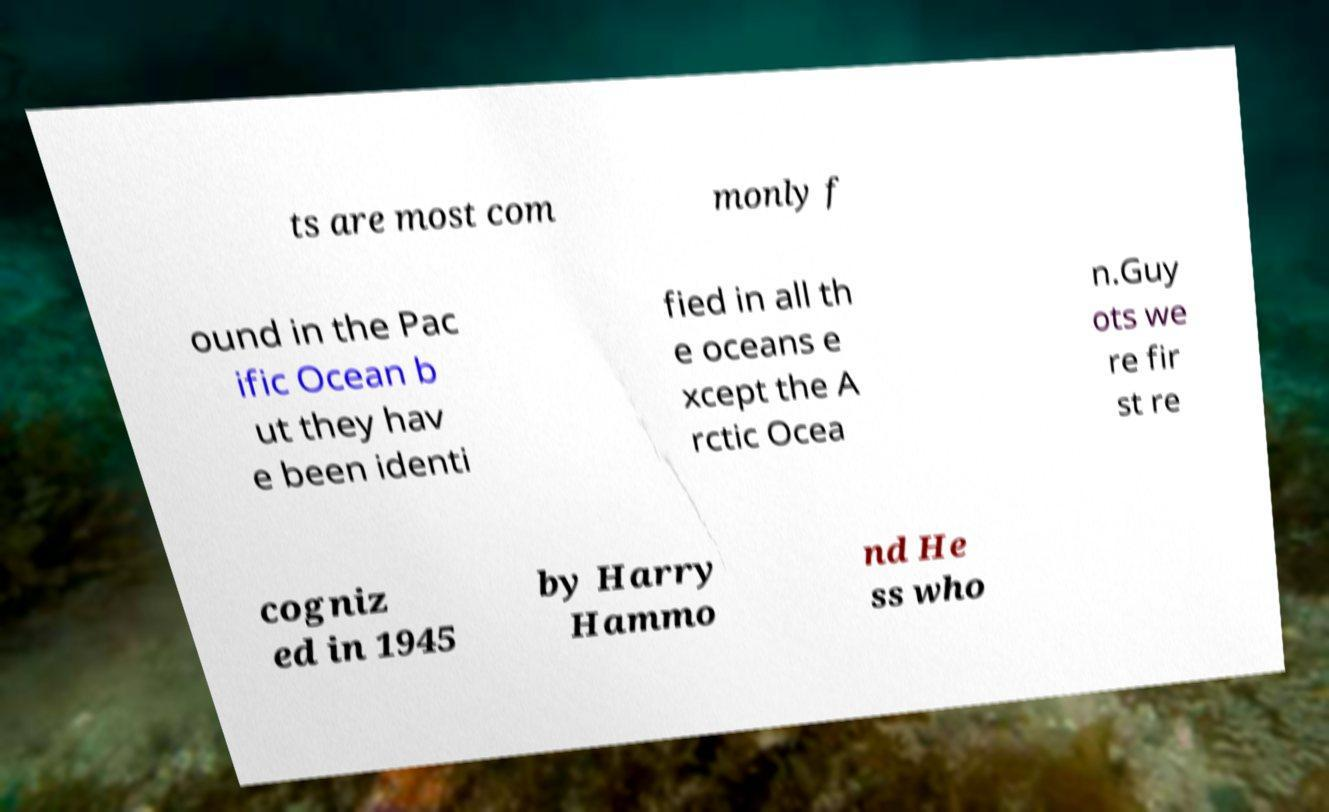Please read and relay the text visible in this image. What does it say? ts are most com monly f ound in the Pac ific Ocean b ut they hav e been identi fied in all th e oceans e xcept the A rctic Ocea n.Guy ots we re fir st re cogniz ed in 1945 by Harry Hammo nd He ss who 